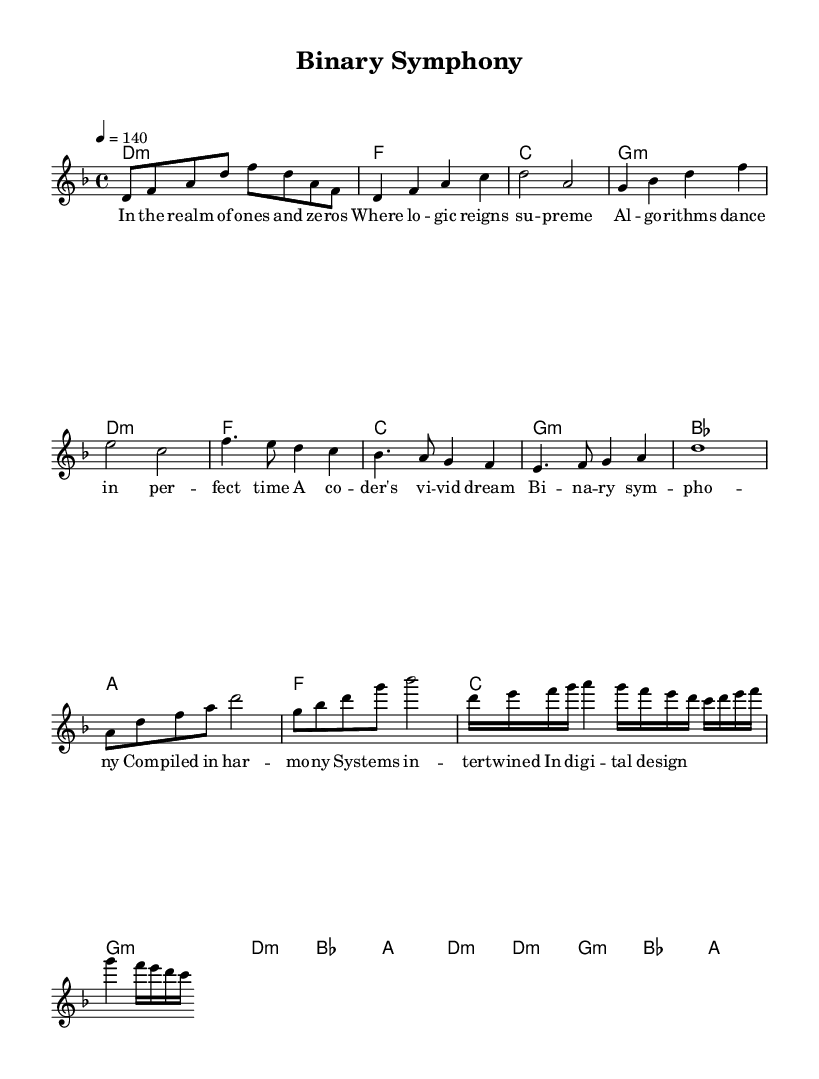What is the key signature of this music? The key signature is indicated by the presence of one flat (B) in the melody and harmony sections, corresponding to D minor.
Answer: D minor What is the time signature of this music? The time signature is shown at the beginning, with a "4/4" indicating four beats per measure.
Answer: 4/4 What is the tempo marking of the piece? The tempo marking shows "4 = 140", which indicates that there are 140 beats per minute.
Answer: 140 What is the structure of the song? The song is organized into sections: Intro, Verse, Chorus, Bridge, and Guitar Solo, which can be inferred from the labels and the flow of the music.
Answer: Intro, Verse, Chorus, Bridge, Guitar Solo How many measures are in the chorus? The chorus section is indicated within the music, and it consists of 8 measures, marked clearly by the melody and harmony parts.
Answer: 8 What lyrical theme is prevalent in the song? The lyrics reflect themes of digital technology and programming, particularly the concepts of binary and algorithms, as articulated in the text content of the verses and chorus.
Answer: Digital technology, algorithms Which section of the song contains the guitar solo? The guitar solo is explicitly labeled in the sheet music and is located after the bridge, indicating a distinct musical section.
Answer: Guitar Solo 